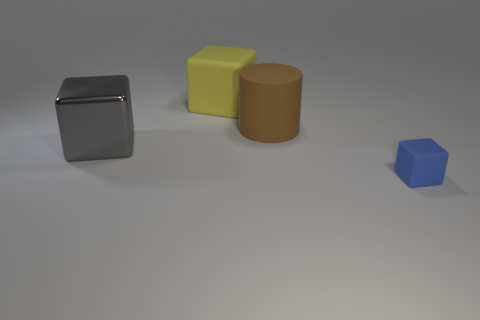Subtract all tiny blue blocks. How many blocks are left? 2 Add 1 large matte cylinders. How many objects exist? 5 Subtract all cylinders. How many objects are left? 3 Subtract all gray blocks. How many blocks are left? 2 Subtract 0 cyan cylinders. How many objects are left? 4 Subtract all gray cylinders. Subtract all brown cubes. How many cylinders are left? 1 Subtract all tiny cyan metal balls. Subtract all big yellow objects. How many objects are left? 3 Add 1 tiny matte blocks. How many tiny matte blocks are left? 2 Add 3 cyan cubes. How many cyan cubes exist? 3 